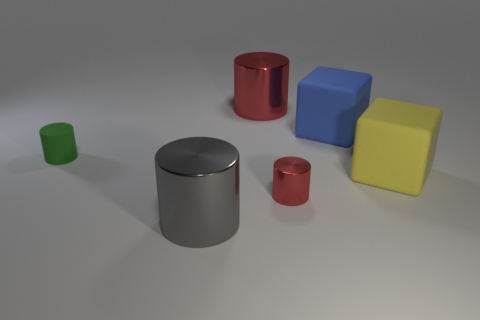Is there a large red object of the same shape as the large yellow thing?
Offer a very short reply. No. There is a large rubber object behind the big thing right of the blue rubber object; what is its shape?
Provide a succinct answer. Cube. How many balls are either large blue objects or cyan things?
Provide a succinct answer. 0. There is a large cylinder that is the same color as the tiny shiny thing; what is it made of?
Keep it short and to the point. Metal. Do the red object behind the tiny green cylinder and the green rubber object that is to the left of the blue rubber thing have the same shape?
Keep it short and to the point. Yes. What color is the matte object that is right of the gray cylinder and on the left side of the big yellow object?
Provide a short and direct response. Blue. There is a tiny matte thing; is it the same color as the large object that is behind the large blue rubber block?
Your response must be concise. No. There is a object that is in front of the big yellow object and right of the large red cylinder; what is its size?
Give a very brief answer. Small. What number of other objects are the same color as the small metallic thing?
Offer a very short reply. 1. There is a red metallic thing left of the small object that is in front of the green matte cylinder to the left of the blue thing; how big is it?
Provide a succinct answer. Large. 